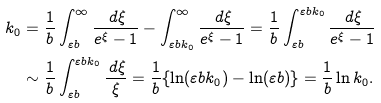<formula> <loc_0><loc_0><loc_500><loc_500>k _ { 0 } & = \frac { 1 } { b } \int _ { \varepsilon b } ^ { \infty } \frac { \, d \xi } { e ^ { \xi } - 1 } - \int ^ { \infty } _ { \varepsilon b k _ { 0 } } \frac { \, d \xi } { e ^ { \xi } - 1 } = \frac { 1 } { b } \int ^ { \varepsilon b k _ { 0 } } _ { \varepsilon b } \frac { \, d \xi } { e ^ { \xi } - 1 } \\ & \sim \frac { 1 } { b } \int ^ { \varepsilon b k _ { 0 } } _ { \varepsilon b } \frac { \, d \xi } \xi = \frac { 1 } { b } \{ \ln ( \varepsilon b k _ { 0 } ) - \ln ( \varepsilon b ) \} = \frac { 1 } { b } \ln k _ { 0 } .</formula> 